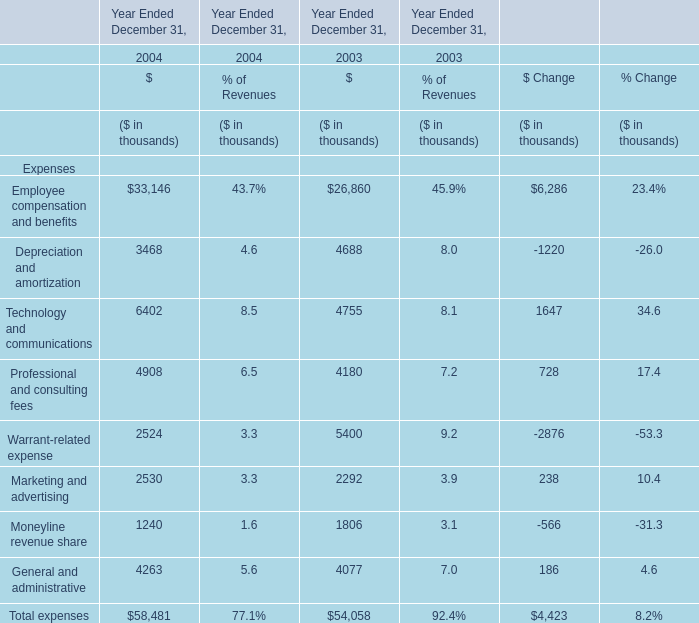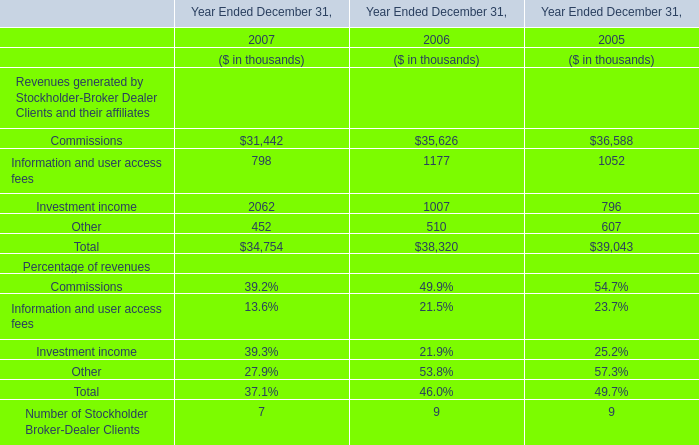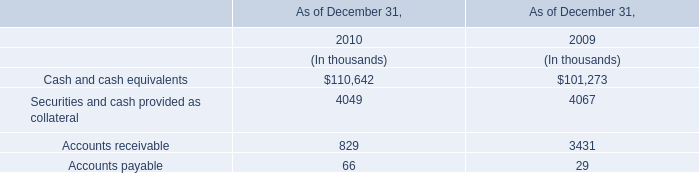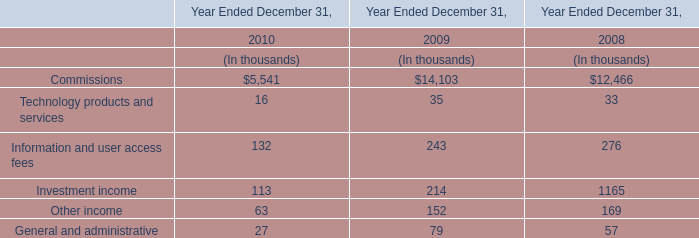What's the average of the Information and user access fees in the years where Accounts receivable is greater than 0? (in thousand) 
Computations: ((132 + 243) / 2)
Answer: 187.5. 